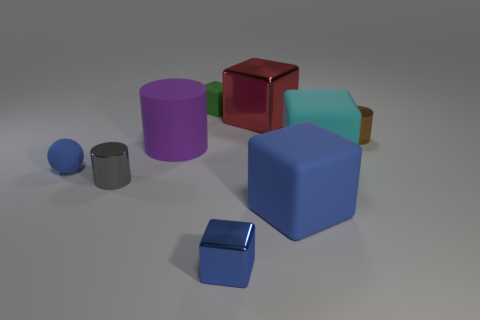There is a small shiny object that is to the left of the small blue metallic thing; what number of gray shiny cylinders are in front of it?
Your answer should be very brief. 0. Are there any tiny cylinders to the right of the brown shiny object?
Ensure brevity in your answer.  No. There is a blue matte thing that is on the right side of the tiny blue thing that is in front of the large blue block; what shape is it?
Keep it short and to the point. Cube. Is the number of red metallic blocks that are right of the brown metallic object less than the number of big purple matte objects behind the tiny green matte thing?
Provide a succinct answer. No. What color is the rubber thing that is the same shape as the gray metal thing?
Provide a succinct answer. Purple. What number of objects are both on the right side of the gray thing and in front of the cyan matte object?
Give a very brief answer. 2. Is the number of brown metal objects that are in front of the small blue shiny block greater than the number of big cyan blocks behind the big red shiny thing?
Make the answer very short. No. How big is the ball?
Your response must be concise. Small. Are there any green metal things of the same shape as the big purple matte object?
Keep it short and to the point. No. There is a red shiny object; is it the same shape as the small rubber thing right of the large cylinder?
Offer a very short reply. Yes. 